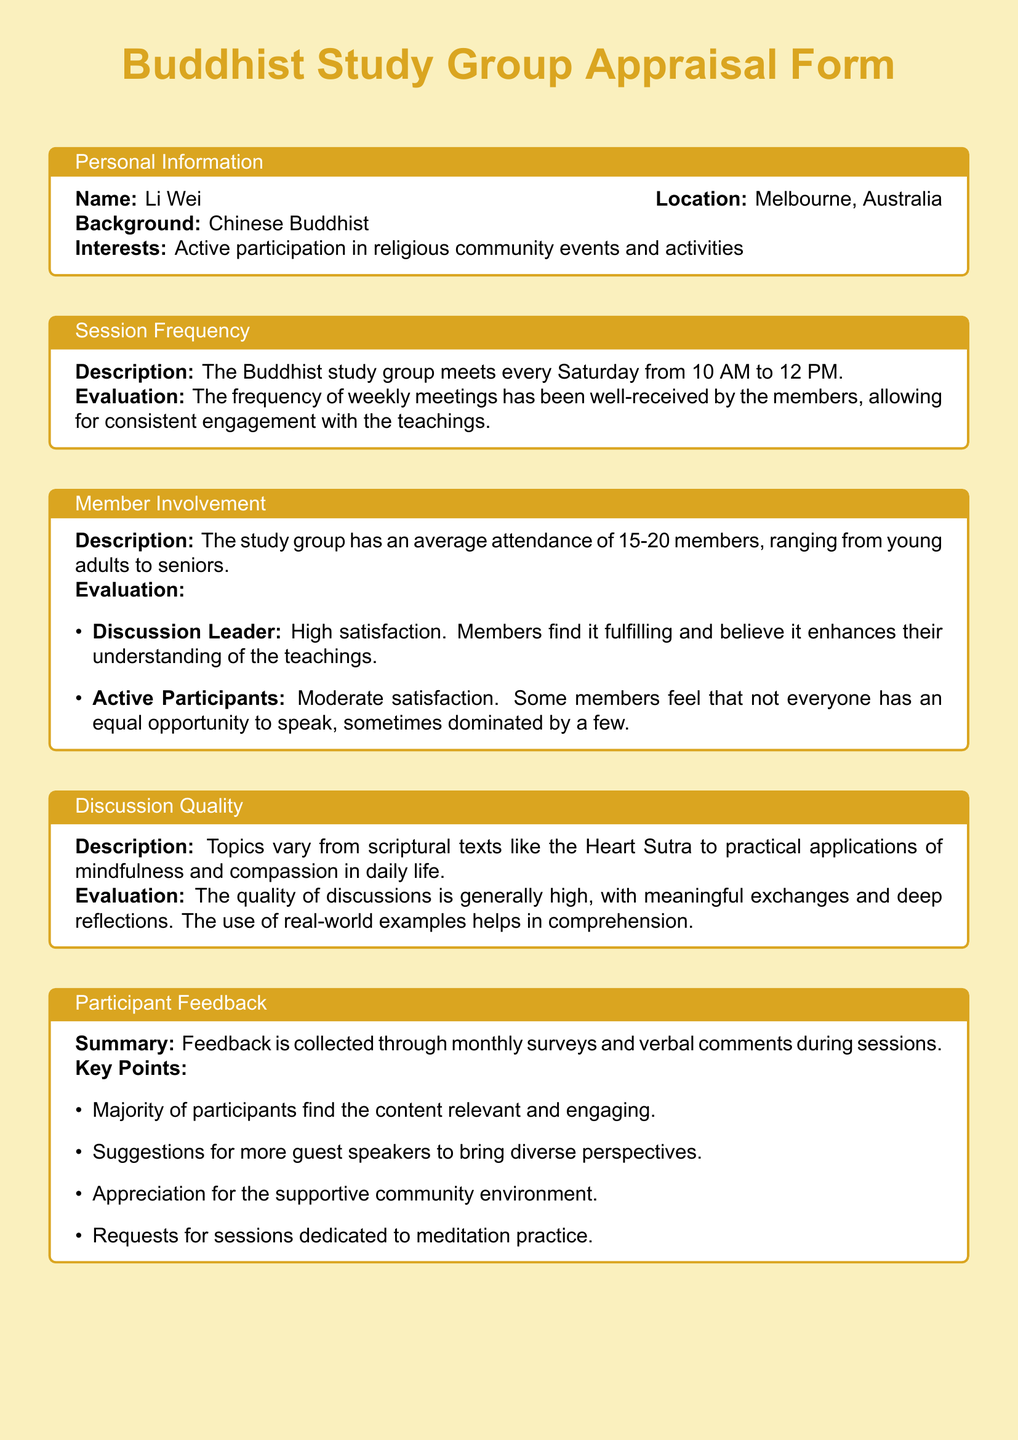What is the meeting frequency of the Buddhist study group? The meeting frequency is specified in the section about Session Frequency as every Saturday.
Answer: every Saturday How many members attend the study group on average? The document states the average attendance in the Member Involvement section as ranging from 15-20 members.
Answer: 15-20 members What is one of the key topics discussed during the sessions? A key topic mentioned in the Discussion Quality section is the Heart Sutra.
Answer: Heart Sutra What kind of feedback is collected from participants? The document mentions feedback collection methods in the Participant Feedback section, which includes monthly surveys and verbal comments.
Answer: monthly surveys and verbal comments What is a suggestion made by participants regarding session content? The document outlines suggestions in the Participant Feedback section, specifically for more guest speakers.
Answer: more guest speakers What aspect of discussions received moderate satisfaction? The evaluation talks about Active Participants in the Member Involvement section, indicating that some feel not everyone has an equal opportunity to speak.
Answer: Active Participants Which days do the sessions take place? The Session Frequency section specifies the day of the week for meetings.
Answer: Saturday What do members appreciate about the community? The document mentions appreciation in the Participant Feedback section about the supportive community environment.
Answer: supportive community environment What is a topic some participants requested dedicated sessions for? Requests for sessions dedicated to this practice are mentioned in the Participant Feedback section, which is meditation practice.
Answer: meditation practice 